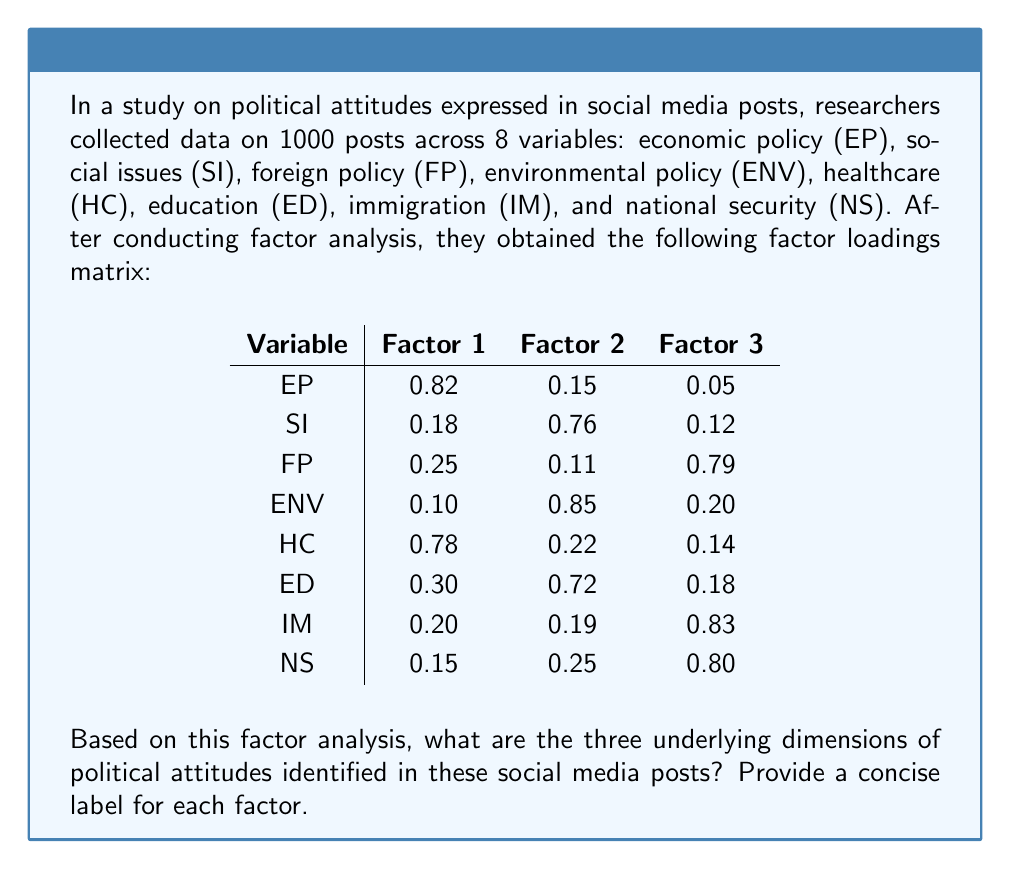Solve this math problem. To interpret the results of factor analysis and identify the underlying dimensions:

1. Examine the factor loadings for each variable across the three factors.
2. Identify which variables load highly (typically > 0.5) on each factor.
3. Look for patterns or themes among the variables that load highly on each factor.
4. Assign a concise label to each factor based on these patterns.

Factor 1:
- High loadings: EP (0.82) and HC (0.78)
- These variables relate to economic and healthcare policies
- Label: "Domestic Economic Policy"

Factor 2:
- High loadings: SI (0.76), ENV (0.85), and ED (0.72)
- These variables relate to social issues, environment, and education
- Label: "Social and Environmental Issues"

Factor 3:
- High loadings: FP (0.79), IM (0.83), and NS (0.80)
- These variables relate to foreign policy, immigration, and national security
- Label: "International Affairs and Security"

These three factors represent the underlying dimensions of political attitudes expressed in the analyzed social media posts.
Answer: 1. Domestic Economic Policy
2. Social and Environmental Issues
3. International Affairs and Security 